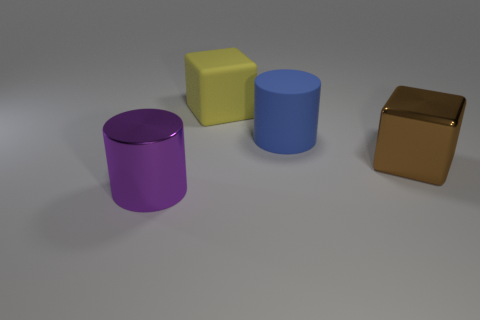Add 3 brown cylinders. How many objects exist? 7 Subtract all purple cylinders. How many cylinders are left? 1 Subtract all purple balls. How many blue cubes are left? 0 Subtract 1 blocks. How many blocks are left? 1 Subtract 0 cyan cylinders. How many objects are left? 4 Subtract all cyan blocks. Subtract all brown cylinders. How many blocks are left? 2 Subtract all big blue objects. Subtract all metal things. How many objects are left? 1 Add 3 big metallic things. How many big metallic things are left? 5 Add 1 tiny red matte blocks. How many tiny red matte blocks exist? 1 